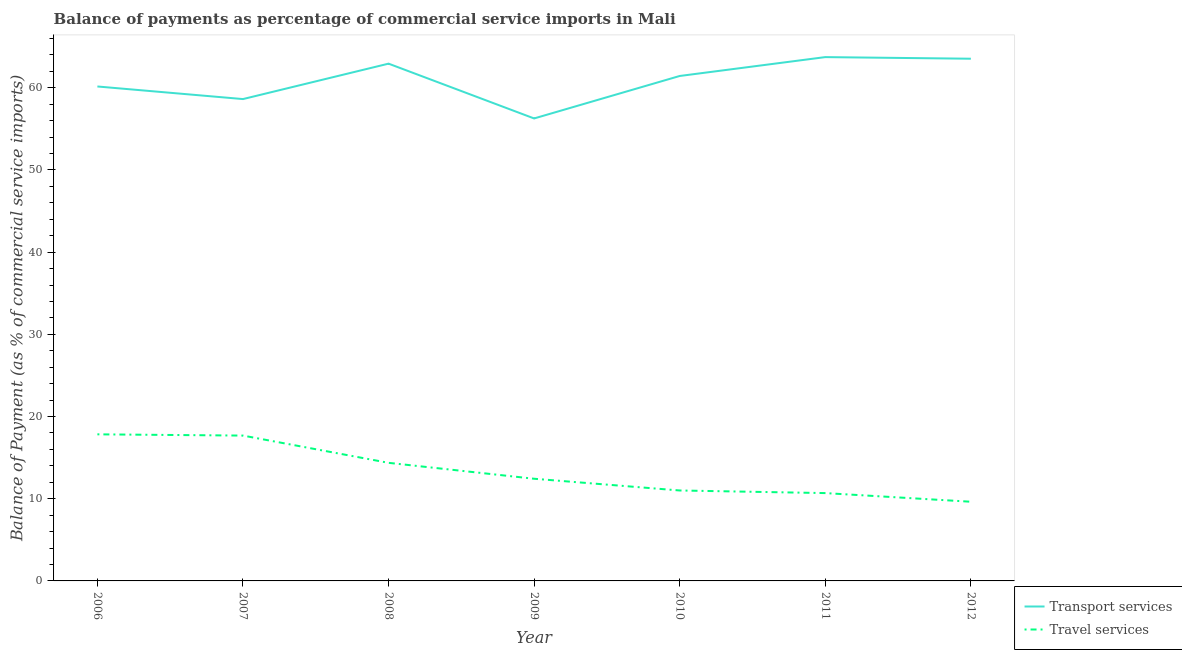Is the number of lines equal to the number of legend labels?
Your response must be concise. Yes. What is the balance of payments of travel services in 2011?
Your answer should be compact. 10.69. Across all years, what is the maximum balance of payments of transport services?
Your answer should be very brief. 63.74. Across all years, what is the minimum balance of payments of transport services?
Provide a short and direct response. 56.27. In which year was the balance of payments of transport services maximum?
Your answer should be very brief. 2011. In which year was the balance of payments of travel services minimum?
Your answer should be very brief. 2012. What is the total balance of payments of transport services in the graph?
Provide a short and direct response. 426.71. What is the difference between the balance of payments of transport services in 2006 and that in 2008?
Keep it short and to the point. -2.78. What is the difference between the balance of payments of transport services in 2007 and the balance of payments of travel services in 2008?
Your answer should be very brief. 44.26. What is the average balance of payments of transport services per year?
Offer a very short reply. 60.96. In the year 2008, what is the difference between the balance of payments of travel services and balance of payments of transport services?
Provide a short and direct response. -48.57. In how many years, is the balance of payments of travel services greater than 56 %?
Offer a very short reply. 0. What is the ratio of the balance of payments of travel services in 2007 to that in 2011?
Offer a very short reply. 1.65. Is the balance of payments of travel services in 2010 less than that in 2012?
Your response must be concise. No. What is the difference between the highest and the second highest balance of payments of travel services?
Your answer should be compact. 0.15. What is the difference between the highest and the lowest balance of payments of travel services?
Your response must be concise. 8.2. Is the sum of the balance of payments of travel services in 2006 and 2008 greater than the maximum balance of payments of transport services across all years?
Provide a short and direct response. No. How many lines are there?
Make the answer very short. 2. How many years are there in the graph?
Provide a succinct answer. 7. What is the difference between two consecutive major ticks on the Y-axis?
Provide a short and direct response. 10. Are the values on the major ticks of Y-axis written in scientific E-notation?
Your response must be concise. No. Does the graph contain grids?
Your answer should be compact. No. How many legend labels are there?
Keep it short and to the point. 2. What is the title of the graph?
Your response must be concise. Balance of payments as percentage of commercial service imports in Mali. What is the label or title of the Y-axis?
Provide a short and direct response. Balance of Payment (as % of commercial service imports). What is the Balance of Payment (as % of commercial service imports) of Transport services in 2006?
Ensure brevity in your answer.  60.16. What is the Balance of Payment (as % of commercial service imports) of Travel services in 2006?
Your response must be concise. 17.84. What is the Balance of Payment (as % of commercial service imports) in Transport services in 2007?
Your answer should be compact. 58.63. What is the Balance of Payment (as % of commercial service imports) of Travel services in 2007?
Your answer should be compact. 17.68. What is the Balance of Payment (as % of commercial service imports) in Transport services in 2008?
Provide a succinct answer. 62.94. What is the Balance of Payment (as % of commercial service imports) in Travel services in 2008?
Your response must be concise. 14.37. What is the Balance of Payment (as % of commercial service imports) in Transport services in 2009?
Offer a very short reply. 56.27. What is the Balance of Payment (as % of commercial service imports) of Travel services in 2009?
Provide a short and direct response. 12.43. What is the Balance of Payment (as % of commercial service imports) in Transport services in 2010?
Ensure brevity in your answer.  61.44. What is the Balance of Payment (as % of commercial service imports) in Travel services in 2010?
Make the answer very short. 11. What is the Balance of Payment (as % of commercial service imports) in Transport services in 2011?
Offer a terse response. 63.74. What is the Balance of Payment (as % of commercial service imports) in Travel services in 2011?
Offer a very short reply. 10.69. What is the Balance of Payment (as % of commercial service imports) in Transport services in 2012?
Give a very brief answer. 63.54. What is the Balance of Payment (as % of commercial service imports) in Travel services in 2012?
Give a very brief answer. 9.63. Across all years, what is the maximum Balance of Payment (as % of commercial service imports) of Transport services?
Provide a short and direct response. 63.74. Across all years, what is the maximum Balance of Payment (as % of commercial service imports) in Travel services?
Give a very brief answer. 17.84. Across all years, what is the minimum Balance of Payment (as % of commercial service imports) in Transport services?
Give a very brief answer. 56.27. Across all years, what is the minimum Balance of Payment (as % of commercial service imports) in Travel services?
Ensure brevity in your answer.  9.63. What is the total Balance of Payment (as % of commercial service imports) of Transport services in the graph?
Offer a very short reply. 426.71. What is the total Balance of Payment (as % of commercial service imports) in Travel services in the graph?
Make the answer very short. 93.65. What is the difference between the Balance of Payment (as % of commercial service imports) in Transport services in 2006 and that in 2007?
Provide a short and direct response. 1.53. What is the difference between the Balance of Payment (as % of commercial service imports) of Travel services in 2006 and that in 2007?
Your answer should be very brief. 0.15. What is the difference between the Balance of Payment (as % of commercial service imports) of Transport services in 2006 and that in 2008?
Make the answer very short. -2.78. What is the difference between the Balance of Payment (as % of commercial service imports) in Travel services in 2006 and that in 2008?
Your response must be concise. 3.47. What is the difference between the Balance of Payment (as % of commercial service imports) of Transport services in 2006 and that in 2009?
Your response must be concise. 3.89. What is the difference between the Balance of Payment (as % of commercial service imports) in Travel services in 2006 and that in 2009?
Your answer should be very brief. 5.4. What is the difference between the Balance of Payment (as % of commercial service imports) in Transport services in 2006 and that in 2010?
Make the answer very short. -1.28. What is the difference between the Balance of Payment (as % of commercial service imports) of Travel services in 2006 and that in 2010?
Your response must be concise. 6.83. What is the difference between the Balance of Payment (as % of commercial service imports) of Transport services in 2006 and that in 2011?
Ensure brevity in your answer.  -3.57. What is the difference between the Balance of Payment (as % of commercial service imports) in Travel services in 2006 and that in 2011?
Make the answer very short. 7.15. What is the difference between the Balance of Payment (as % of commercial service imports) of Transport services in 2006 and that in 2012?
Your answer should be very brief. -3.38. What is the difference between the Balance of Payment (as % of commercial service imports) in Travel services in 2006 and that in 2012?
Give a very brief answer. 8.2. What is the difference between the Balance of Payment (as % of commercial service imports) of Transport services in 2007 and that in 2008?
Make the answer very short. -4.31. What is the difference between the Balance of Payment (as % of commercial service imports) of Travel services in 2007 and that in 2008?
Provide a short and direct response. 3.32. What is the difference between the Balance of Payment (as % of commercial service imports) in Transport services in 2007 and that in 2009?
Ensure brevity in your answer.  2.36. What is the difference between the Balance of Payment (as % of commercial service imports) of Travel services in 2007 and that in 2009?
Your answer should be very brief. 5.25. What is the difference between the Balance of Payment (as % of commercial service imports) in Transport services in 2007 and that in 2010?
Provide a short and direct response. -2.81. What is the difference between the Balance of Payment (as % of commercial service imports) in Travel services in 2007 and that in 2010?
Ensure brevity in your answer.  6.68. What is the difference between the Balance of Payment (as % of commercial service imports) in Transport services in 2007 and that in 2011?
Offer a very short reply. -5.11. What is the difference between the Balance of Payment (as % of commercial service imports) of Travel services in 2007 and that in 2011?
Provide a short and direct response. 7. What is the difference between the Balance of Payment (as % of commercial service imports) of Transport services in 2007 and that in 2012?
Provide a succinct answer. -4.91. What is the difference between the Balance of Payment (as % of commercial service imports) of Travel services in 2007 and that in 2012?
Your response must be concise. 8.05. What is the difference between the Balance of Payment (as % of commercial service imports) of Transport services in 2008 and that in 2009?
Keep it short and to the point. 6.67. What is the difference between the Balance of Payment (as % of commercial service imports) of Travel services in 2008 and that in 2009?
Offer a terse response. 1.94. What is the difference between the Balance of Payment (as % of commercial service imports) in Transport services in 2008 and that in 2010?
Offer a terse response. 1.5. What is the difference between the Balance of Payment (as % of commercial service imports) of Travel services in 2008 and that in 2010?
Your answer should be compact. 3.36. What is the difference between the Balance of Payment (as % of commercial service imports) in Transport services in 2008 and that in 2011?
Offer a very short reply. -0.8. What is the difference between the Balance of Payment (as % of commercial service imports) in Travel services in 2008 and that in 2011?
Ensure brevity in your answer.  3.68. What is the difference between the Balance of Payment (as % of commercial service imports) in Transport services in 2008 and that in 2012?
Offer a terse response. -0.6. What is the difference between the Balance of Payment (as % of commercial service imports) of Travel services in 2008 and that in 2012?
Provide a succinct answer. 4.73. What is the difference between the Balance of Payment (as % of commercial service imports) of Transport services in 2009 and that in 2010?
Offer a terse response. -5.17. What is the difference between the Balance of Payment (as % of commercial service imports) in Travel services in 2009 and that in 2010?
Your response must be concise. 1.43. What is the difference between the Balance of Payment (as % of commercial service imports) of Transport services in 2009 and that in 2011?
Give a very brief answer. -7.46. What is the difference between the Balance of Payment (as % of commercial service imports) of Travel services in 2009 and that in 2011?
Provide a short and direct response. 1.75. What is the difference between the Balance of Payment (as % of commercial service imports) of Transport services in 2009 and that in 2012?
Your answer should be compact. -7.27. What is the difference between the Balance of Payment (as % of commercial service imports) of Travel services in 2009 and that in 2012?
Provide a succinct answer. 2.8. What is the difference between the Balance of Payment (as % of commercial service imports) in Transport services in 2010 and that in 2011?
Your answer should be compact. -2.3. What is the difference between the Balance of Payment (as % of commercial service imports) in Travel services in 2010 and that in 2011?
Keep it short and to the point. 0.32. What is the difference between the Balance of Payment (as % of commercial service imports) of Transport services in 2010 and that in 2012?
Your response must be concise. -2.1. What is the difference between the Balance of Payment (as % of commercial service imports) of Travel services in 2010 and that in 2012?
Your answer should be compact. 1.37. What is the difference between the Balance of Payment (as % of commercial service imports) in Transport services in 2011 and that in 2012?
Provide a succinct answer. 0.2. What is the difference between the Balance of Payment (as % of commercial service imports) of Travel services in 2011 and that in 2012?
Provide a short and direct response. 1.05. What is the difference between the Balance of Payment (as % of commercial service imports) in Transport services in 2006 and the Balance of Payment (as % of commercial service imports) in Travel services in 2007?
Ensure brevity in your answer.  42.48. What is the difference between the Balance of Payment (as % of commercial service imports) in Transport services in 2006 and the Balance of Payment (as % of commercial service imports) in Travel services in 2008?
Make the answer very short. 45.79. What is the difference between the Balance of Payment (as % of commercial service imports) in Transport services in 2006 and the Balance of Payment (as % of commercial service imports) in Travel services in 2009?
Offer a very short reply. 47.73. What is the difference between the Balance of Payment (as % of commercial service imports) of Transport services in 2006 and the Balance of Payment (as % of commercial service imports) of Travel services in 2010?
Provide a short and direct response. 49.16. What is the difference between the Balance of Payment (as % of commercial service imports) in Transport services in 2006 and the Balance of Payment (as % of commercial service imports) in Travel services in 2011?
Your answer should be very brief. 49.47. What is the difference between the Balance of Payment (as % of commercial service imports) of Transport services in 2006 and the Balance of Payment (as % of commercial service imports) of Travel services in 2012?
Offer a terse response. 50.53. What is the difference between the Balance of Payment (as % of commercial service imports) of Transport services in 2007 and the Balance of Payment (as % of commercial service imports) of Travel services in 2008?
Offer a very short reply. 44.26. What is the difference between the Balance of Payment (as % of commercial service imports) in Transport services in 2007 and the Balance of Payment (as % of commercial service imports) in Travel services in 2009?
Offer a terse response. 46.2. What is the difference between the Balance of Payment (as % of commercial service imports) of Transport services in 2007 and the Balance of Payment (as % of commercial service imports) of Travel services in 2010?
Provide a short and direct response. 47.63. What is the difference between the Balance of Payment (as % of commercial service imports) of Transport services in 2007 and the Balance of Payment (as % of commercial service imports) of Travel services in 2011?
Your answer should be very brief. 47.94. What is the difference between the Balance of Payment (as % of commercial service imports) in Transport services in 2007 and the Balance of Payment (as % of commercial service imports) in Travel services in 2012?
Ensure brevity in your answer.  48.99. What is the difference between the Balance of Payment (as % of commercial service imports) of Transport services in 2008 and the Balance of Payment (as % of commercial service imports) of Travel services in 2009?
Keep it short and to the point. 50.51. What is the difference between the Balance of Payment (as % of commercial service imports) of Transport services in 2008 and the Balance of Payment (as % of commercial service imports) of Travel services in 2010?
Provide a succinct answer. 51.93. What is the difference between the Balance of Payment (as % of commercial service imports) of Transport services in 2008 and the Balance of Payment (as % of commercial service imports) of Travel services in 2011?
Ensure brevity in your answer.  52.25. What is the difference between the Balance of Payment (as % of commercial service imports) in Transport services in 2008 and the Balance of Payment (as % of commercial service imports) in Travel services in 2012?
Provide a short and direct response. 53.3. What is the difference between the Balance of Payment (as % of commercial service imports) of Transport services in 2009 and the Balance of Payment (as % of commercial service imports) of Travel services in 2010?
Your response must be concise. 45.27. What is the difference between the Balance of Payment (as % of commercial service imports) in Transport services in 2009 and the Balance of Payment (as % of commercial service imports) in Travel services in 2011?
Your response must be concise. 45.59. What is the difference between the Balance of Payment (as % of commercial service imports) in Transport services in 2009 and the Balance of Payment (as % of commercial service imports) in Travel services in 2012?
Your response must be concise. 46.64. What is the difference between the Balance of Payment (as % of commercial service imports) in Transport services in 2010 and the Balance of Payment (as % of commercial service imports) in Travel services in 2011?
Offer a very short reply. 50.75. What is the difference between the Balance of Payment (as % of commercial service imports) of Transport services in 2010 and the Balance of Payment (as % of commercial service imports) of Travel services in 2012?
Provide a succinct answer. 51.8. What is the difference between the Balance of Payment (as % of commercial service imports) of Transport services in 2011 and the Balance of Payment (as % of commercial service imports) of Travel services in 2012?
Your answer should be very brief. 54.1. What is the average Balance of Payment (as % of commercial service imports) in Transport services per year?
Your answer should be compact. 60.96. What is the average Balance of Payment (as % of commercial service imports) of Travel services per year?
Offer a terse response. 13.38. In the year 2006, what is the difference between the Balance of Payment (as % of commercial service imports) of Transport services and Balance of Payment (as % of commercial service imports) of Travel services?
Provide a succinct answer. 42.33. In the year 2007, what is the difference between the Balance of Payment (as % of commercial service imports) in Transport services and Balance of Payment (as % of commercial service imports) in Travel services?
Your response must be concise. 40.95. In the year 2008, what is the difference between the Balance of Payment (as % of commercial service imports) of Transport services and Balance of Payment (as % of commercial service imports) of Travel services?
Your answer should be very brief. 48.57. In the year 2009, what is the difference between the Balance of Payment (as % of commercial service imports) in Transport services and Balance of Payment (as % of commercial service imports) in Travel services?
Your response must be concise. 43.84. In the year 2010, what is the difference between the Balance of Payment (as % of commercial service imports) in Transport services and Balance of Payment (as % of commercial service imports) in Travel services?
Provide a short and direct response. 50.44. In the year 2011, what is the difference between the Balance of Payment (as % of commercial service imports) in Transport services and Balance of Payment (as % of commercial service imports) in Travel services?
Your answer should be compact. 53.05. In the year 2012, what is the difference between the Balance of Payment (as % of commercial service imports) of Transport services and Balance of Payment (as % of commercial service imports) of Travel services?
Provide a short and direct response. 53.91. What is the ratio of the Balance of Payment (as % of commercial service imports) in Transport services in 2006 to that in 2007?
Your answer should be very brief. 1.03. What is the ratio of the Balance of Payment (as % of commercial service imports) in Travel services in 2006 to that in 2007?
Provide a short and direct response. 1.01. What is the ratio of the Balance of Payment (as % of commercial service imports) of Transport services in 2006 to that in 2008?
Your answer should be very brief. 0.96. What is the ratio of the Balance of Payment (as % of commercial service imports) in Travel services in 2006 to that in 2008?
Make the answer very short. 1.24. What is the ratio of the Balance of Payment (as % of commercial service imports) of Transport services in 2006 to that in 2009?
Ensure brevity in your answer.  1.07. What is the ratio of the Balance of Payment (as % of commercial service imports) of Travel services in 2006 to that in 2009?
Offer a very short reply. 1.43. What is the ratio of the Balance of Payment (as % of commercial service imports) in Transport services in 2006 to that in 2010?
Your answer should be very brief. 0.98. What is the ratio of the Balance of Payment (as % of commercial service imports) of Travel services in 2006 to that in 2010?
Give a very brief answer. 1.62. What is the ratio of the Balance of Payment (as % of commercial service imports) of Transport services in 2006 to that in 2011?
Your response must be concise. 0.94. What is the ratio of the Balance of Payment (as % of commercial service imports) of Travel services in 2006 to that in 2011?
Keep it short and to the point. 1.67. What is the ratio of the Balance of Payment (as % of commercial service imports) of Transport services in 2006 to that in 2012?
Make the answer very short. 0.95. What is the ratio of the Balance of Payment (as % of commercial service imports) in Travel services in 2006 to that in 2012?
Offer a very short reply. 1.85. What is the ratio of the Balance of Payment (as % of commercial service imports) of Transport services in 2007 to that in 2008?
Your response must be concise. 0.93. What is the ratio of the Balance of Payment (as % of commercial service imports) in Travel services in 2007 to that in 2008?
Ensure brevity in your answer.  1.23. What is the ratio of the Balance of Payment (as % of commercial service imports) of Transport services in 2007 to that in 2009?
Keep it short and to the point. 1.04. What is the ratio of the Balance of Payment (as % of commercial service imports) of Travel services in 2007 to that in 2009?
Your answer should be compact. 1.42. What is the ratio of the Balance of Payment (as % of commercial service imports) of Transport services in 2007 to that in 2010?
Provide a succinct answer. 0.95. What is the ratio of the Balance of Payment (as % of commercial service imports) of Travel services in 2007 to that in 2010?
Ensure brevity in your answer.  1.61. What is the ratio of the Balance of Payment (as % of commercial service imports) of Transport services in 2007 to that in 2011?
Your answer should be very brief. 0.92. What is the ratio of the Balance of Payment (as % of commercial service imports) of Travel services in 2007 to that in 2011?
Ensure brevity in your answer.  1.65. What is the ratio of the Balance of Payment (as % of commercial service imports) of Transport services in 2007 to that in 2012?
Provide a succinct answer. 0.92. What is the ratio of the Balance of Payment (as % of commercial service imports) in Travel services in 2007 to that in 2012?
Offer a terse response. 1.84. What is the ratio of the Balance of Payment (as % of commercial service imports) of Transport services in 2008 to that in 2009?
Your answer should be very brief. 1.12. What is the ratio of the Balance of Payment (as % of commercial service imports) in Travel services in 2008 to that in 2009?
Your answer should be compact. 1.16. What is the ratio of the Balance of Payment (as % of commercial service imports) in Transport services in 2008 to that in 2010?
Your answer should be very brief. 1.02. What is the ratio of the Balance of Payment (as % of commercial service imports) in Travel services in 2008 to that in 2010?
Your answer should be compact. 1.31. What is the ratio of the Balance of Payment (as % of commercial service imports) in Transport services in 2008 to that in 2011?
Ensure brevity in your answer.  0.99. What is the ratio of the Balance of Payment (as % of commercial service imports) in Travel services in 2008 to that in 2011?
Provide a short and direct response. 1.34. What is the ratio of the Balance of Payment (as % of commercial service imports) in Travel services in 2008 to that in 2012?
Ensure brevity in your answer.  1.49. What is the ratio of the Balance of Payment (as % of commercial service imports) in Transport services in 2009 to that in 2010?
Make the answer very short. 0.92. What is the ratio of the Balance of Payment (as % of commercial service imports) of Travel services in 2009 to that in 2010?
Make the answer very short. 1.13. What is the ratio of the Balance of Payment (as % of commercial service imports) in Transport services in 2009 to that in 2011?
Provide a succinct answer. 0.88. What is the ratio of the Balance of Payment (as % of commercial service imports) in Travel services in 2009 to that in 2011?
Ensure brevity in your answer.  1.16. What is the ratio of the Balance of Payment (as % of commercial service imports) in Transport services in 2009 to that in 2012?
Offer a very short reply. 0.89. What is the ratio of the Balance of Payment (as % of commercial service imports) in Travel services in 2009 to that in 2012?
Provide a succinct answer. 1.29. What is the ratio of the Balance of Payment (as % of commercial service imports) of Transport services in 2010 to that in 2011?
Keep it short and to the point. 0.96. What is the ratio of the Balance of Payment (as % of commercial service imports) of Travel services in 2010 to that in 2011?
Provide a short and direct response. 1.03. What is the ratio of the Balance of Payment (as % of commercial service imports) of Transport services in 2010 to that in 2012?
Provide a succinct answer. 0.97. What is the ratio of the Balance of Payment (as % of commercial service imports) of Travel services in 2010 to that in 2012?
Make the answer very short. 1.14. What is the ratio of the Balance of Payment (as % of commercial service imports) in Transport services in 2011 to that in 2012?
Provide a short and direct response. 1. What is the ratio of the Balance of Payment (as % of commercial service imports) in Travel services in 2011 to that in 2012?
Keep it short and to the point. 1.11. What is the difference between the highest and the second highest Balance of Payment (as % of commercial service imports) of Transport services?
Provide a succinct answer. 0.2. What is the difference between the highest and the second highest Balance of Payment (as % of commercial service imports) in Travel services?
Your answer should be very brief. 0.15. What is the difference between the highest and the lowest Balance of Payment (as % of commercial service imports) of Transport services?
Provide a succinct answer. 7.46. What is the difference between the highest and the lowest Balance of Payment (as % of commercial service imports) in Travel services?
Your answer should be very brief. 8.2. 